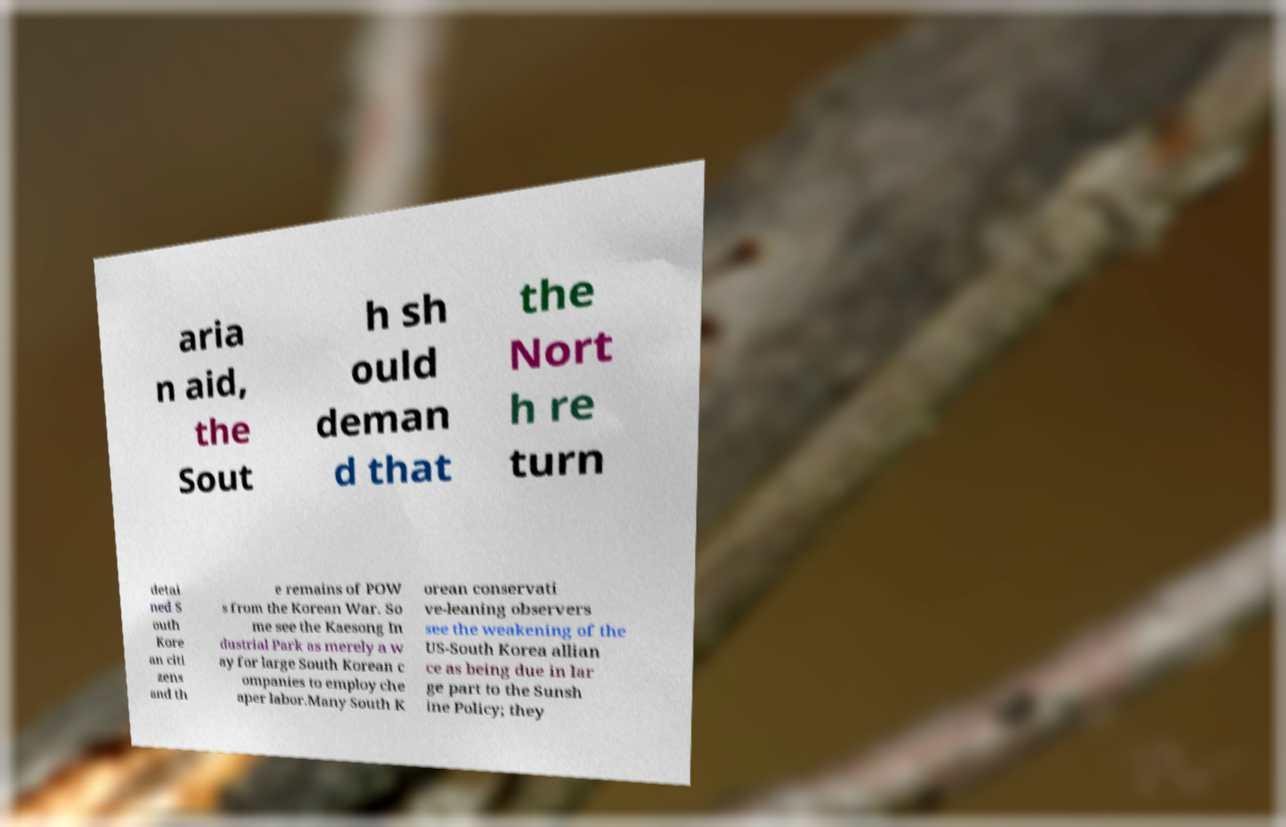There's text embedded in this image that I need extracted. Can you transcribe it verbatim? aria n aid, the Sout h sh ould deman d that the Nort h re turn detai ned S outh Kore an citi zens and th e remains of POW s from the Korean War. So me see the Kaesong In dustrial Park as merely a w ay for large South Korean c ompanies to employ che aper labor.Many South K orean conservati ve-leaning observers see the weakening of the US-South Korea allian ce as being due in lar ge part to the Sunsh ine Policy; they 